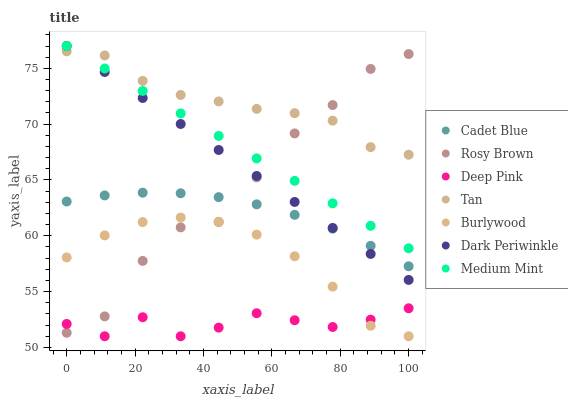Does Deep Pink have the minimum area under the curve?
Answer yes or no. Yes. Does Tan have the maximum area under the curve?
Answer yes or no. Yes. Does Cadet Blue have the minimum area under the curve?
Answer yes or no. No. Does Cadet Blue have the maximum area under the curve?
Answer yes or no. No. Is Dark Periwinkle the smoothest?
Answer yes or no. Yes. Is Rosy Brown the roughest?
Answer yes or no. Yes. Is Cadet Blue the smoothest?
Answer yes or no. No. Is Cadet Blue the roughest?
Answer yes or no. No. Does Burlywood have the lowest value?
Answer yes or no. Yes. Does Cadet Blue have the lowest value?
Answer yes or no. No. Does Dark Periwinkle have the highest value?
Answer yes or no. Yes. Does Cadet Blue have the highest value?
Answer yes or no. No. Is Burlywood less than Medium Mint?
Answer yes or no. Yes. Is Cadet Blue greater than Burlywood?
Answer yes or no. Yes. Does Rosy Brown intersect Burlywood?
Answer yes or no. Yes. Is Rosy Brown less than Burlywood?
Answer yes or no. No. Is Rosy Brown greater than Burlywood?
Answer yes or no. No. Does Burlywood intersect Medium Mint?
Answer yes or no. No. 